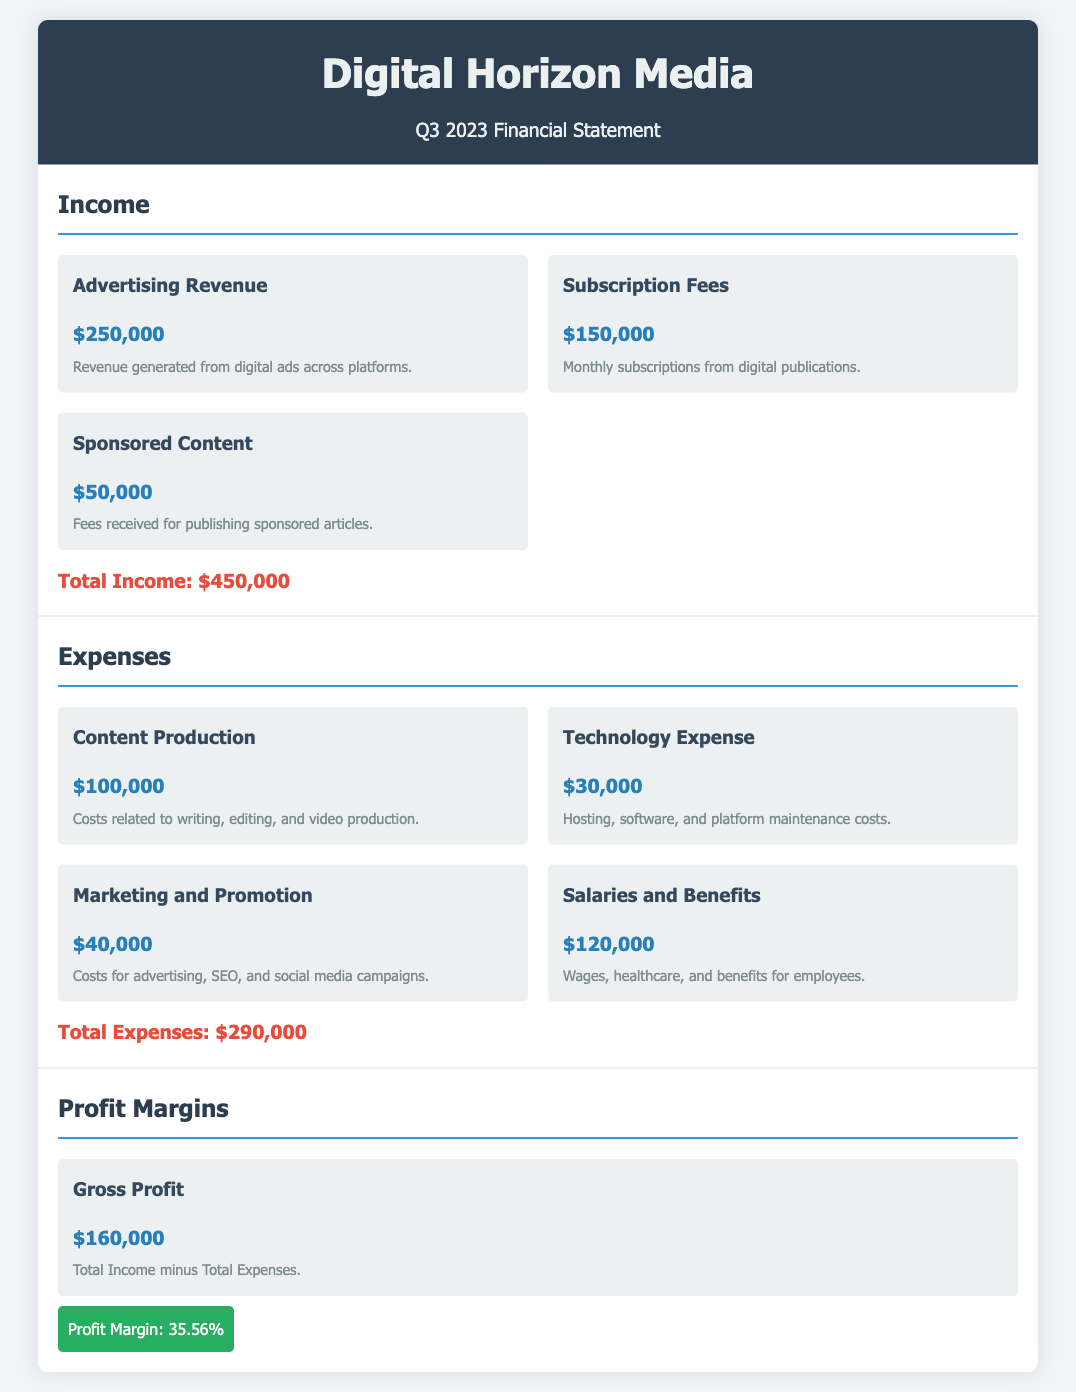What is the total income? The total income is calculated by summing all revenue sources, which is $250,000 from Advertising Revenue, $150,000 from Subscription Fees, and $50,000 from Sponsored Content, resulting in $450,000.
Answer: $450,000 What is the total expenses? The total expenses sum up all expense items, which includes $100,000 for Content Production, $30,000 for Technology Expense, $40,000 for Marketing and Promotion, and $120,000 for Salaries and Benefits, giving a total of $290,000.
Answer: $290,000 What is the Gross Profit? Gross Profit is calculated by subtracting Total Expenses from Total Income, which is $450,000 - $290,000, resulting in $160,000.
Answer: $160,000 What is the Profit Margin percentage? The Profit Margin is expressed as a percentage calculated using Gross Profit divided by Total Income, which is $160,000 / $450,000, giving 35.56%.
Answer: 35.56% What are the Subscription Fees? Subscription Fees are a type of income and specifically refer to the amount collected from monthly subscriptions, which totals $150,000.
Answer: $150,000 What is the expenditure for Salaries and Benefits? Salaries and Benefits represent a specific category of expenses detailing wages and benefits for employees, amounting to $120,000.
Answer: $120,000 Which section details revenue generated from digital ads? The section that describes revenue sourced from digital advertising is labeled "Income," specifically under "Advertising Revenue."
Answer: Advertising Revenue What is the cost related to Technology Expense? Technology Expense is described under the Expenses section, indicating the cost of hosting, software, and platform maintenance, amounting to $30,000.
Answer: $30,000 What is the highest expense listed? The highest expense amount listed is for Salaries and Benefits, which totals $120,000, making it the largest expenditure.
Answer: Salaries and Benefits 